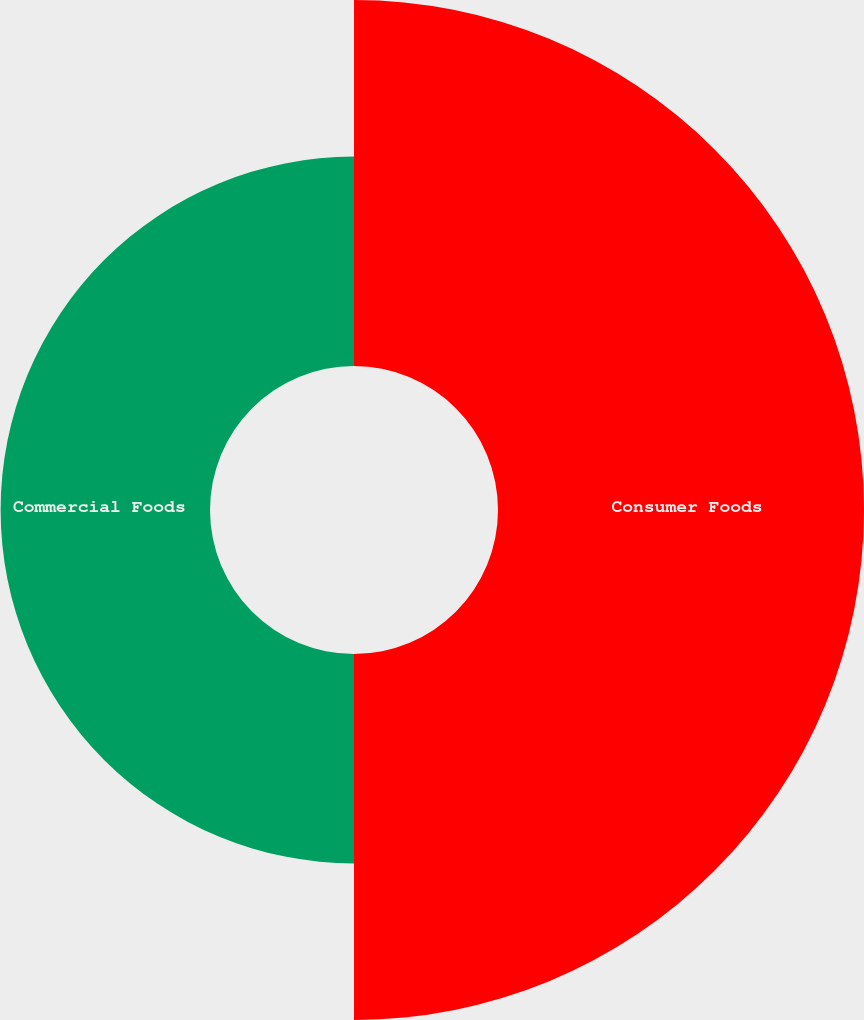Convert chart to OTSL. <chart><loc_0><loc_0><loc_500><loc_500><pie_chart><fcel>Consumer Foods<fcel>Commercial Foods<nl><fcel>63.61%<fcel>36.39%<nl></chart> 